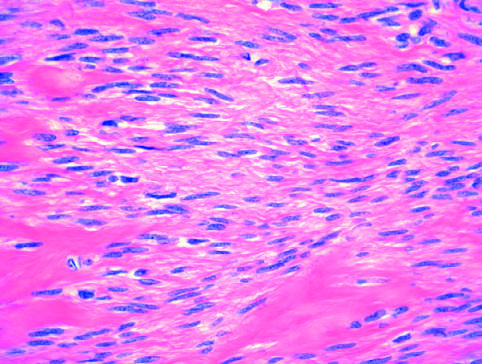does plaque show bundles of normal-looking smooth muscle cells?
Answer the question using a single word or phrase. No 